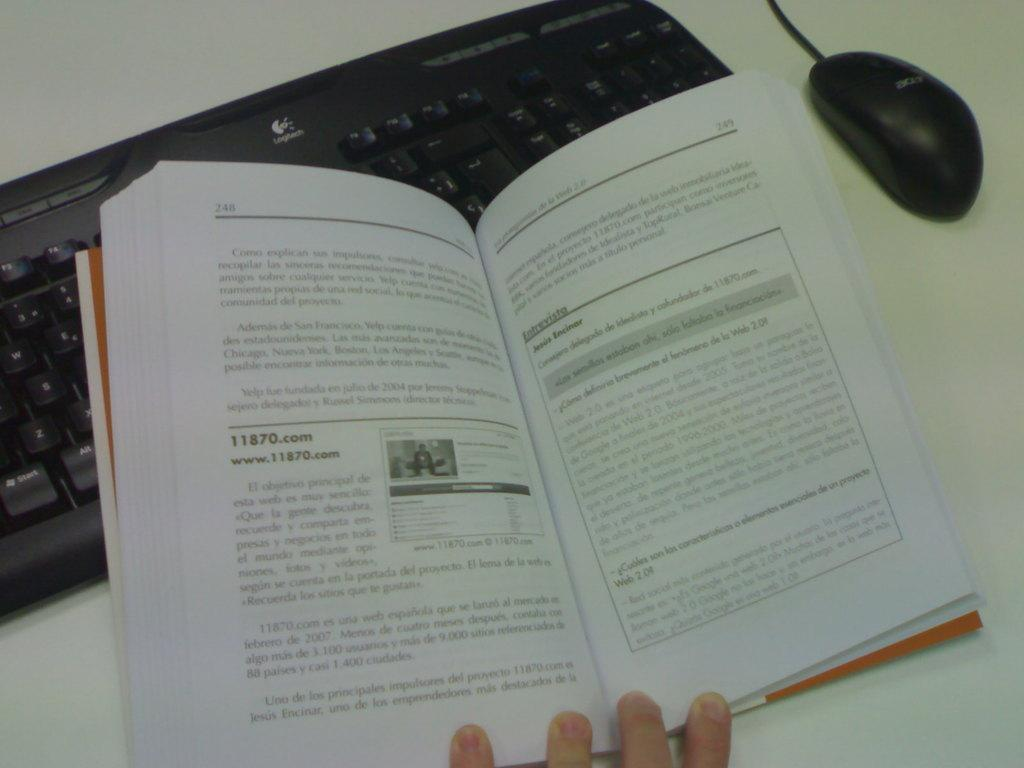<image>
Write a terse but informative summary of the picture. A book is open to page 248 whilst resting on a keyboard. 